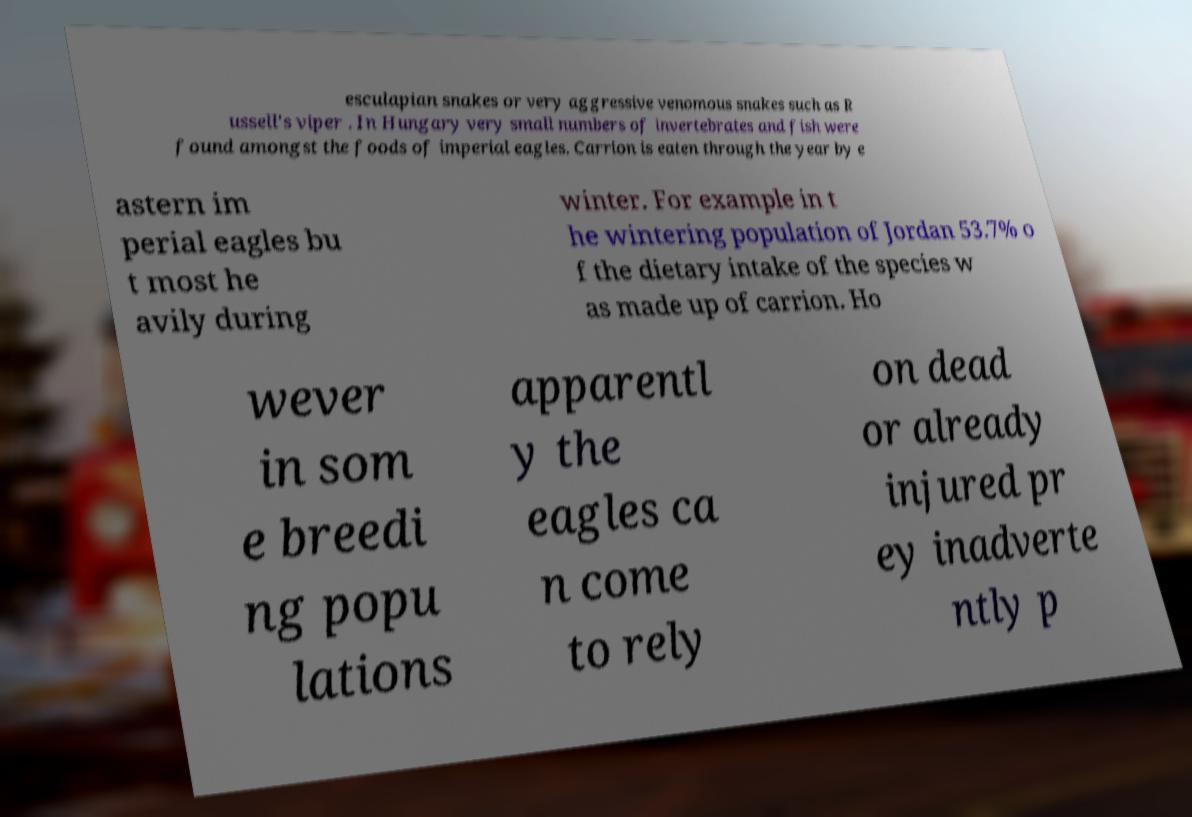Could you extract and type out the text from this image? esculapian snakes or very aggressive venomous snakes such as R ussell's viper . In Hungary very small numbers of invertebrates and fish were found amongst the foods of imperial eagles. Carrion is eaten through the year by e astern im perial eagles bu t most he avily during winter. For example in t he wintering population of Jordan 53.7% o f the dietary intake of the species w as made up of carrion. Ho wever in som e breedi ng popu lations apparentl y the eagles ca n come to rely on dead or already injured pr ey inadverte ntly p 